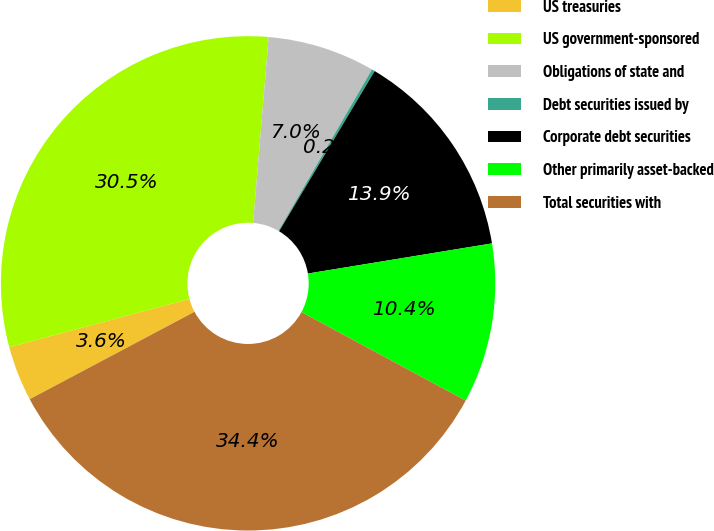Convert chart. <chart><loc_0><loc_0><loc_500><loc_500><pie_chart><fcel>US treasuries<fcel>US government-sponsored<fcel>Obligations of state and<fcel>Debt securities issued by<fcel>Corporate debt securities<fcel>Other primarily asset-backed<fcel>Total securities with<nl><fcel>3.61%<fcel>30.48%<fcel>7.03%<fcel>0.2%<fcel>13.86%<fcel>10.45%<fcel>34.37%<nl></chart> 